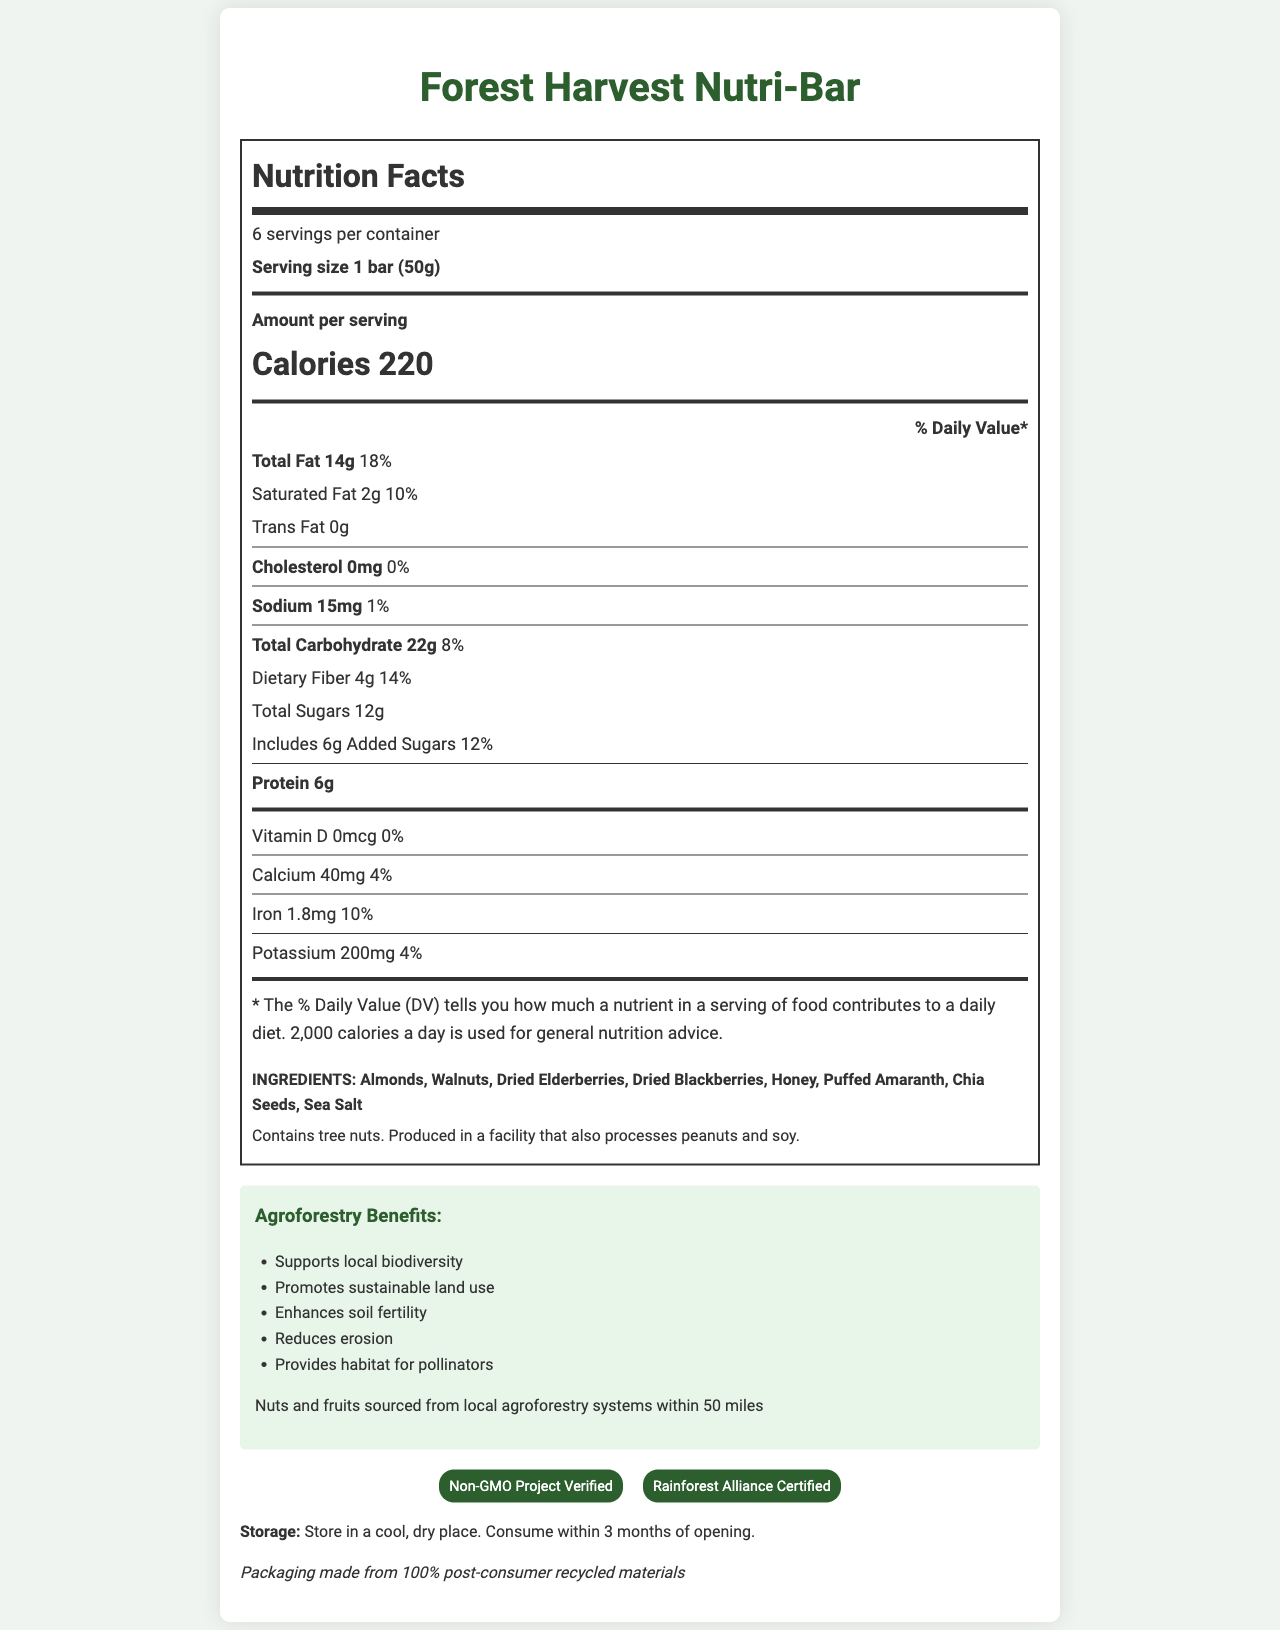what is the serving size of the Forest Harvest Nutri-Bar? The serving size is explicitly mentioned as "1 bar (50g)" in the nutrition label.
Answer: 1 bar (50g) how many servings are there per container? The label clearly states that there are 6 servings per container.
Answer: 6 how many calories are there per serving? The amount of calories per serving is listed as 220.
Answer: 220 what is the amount of total fat in one serving? The total fat amount per serving is listed on the label as 14g.
Answer: 14g how much protein does one serving contain? The label indicates that one serving contains 6g of protein.
Answer: 6g What is the percentage of the daily value for saturated fat per serving? The nutrition label shows that saturated fat is 2g, which is 10% of the daily value.
Answer: 10% Which of the following is included in the ingredients? A. Peanuts B. Almonds C. Cashews The ingredients list does not include peanuts or cashews but does list almonds.
Answer: B What certifications does the Forest Harvest Nutri-Bar have? A. Non-GMO Project Verified B. Certified Organic C. Fair Trade Certified The label only mentions "Non-GMO Project Verified" and "Rainforest Alliance Certified."
Answer: A Is the Forest Harvest Nutri-Bar gluten-free? The document provides no information if the product is gluten-free.
Answer: Not enough information does this snack bar contain any cholesterol? The nutrition label shows 0mg of cholesterol.
Answer: No summarize the main idea of the document. The document provides a detailed view of the nutritional facts, ingredient list, sourcing information, and agroforestry benefits associated with the Forest Harvest Nutri-Bar.
Answer: The Forest Harvest Nutri-Bar is a locally-sourced, nutritious snack made from tree nuts and forest fruits. It supports environmental sustainability and provides nutritional information such as calories, fats, carbohydrates, and protein per serving. does the bar contain any added sugars? The label indicates that there are 6g of added sugars per serving.
Answer: Yes what are the agroforestry benefits associated with this product? The document contains a section listing the agroforestry benefits.
Answer: Supports local biodiversity, Promotes sustainable land use, Enhances soil fertility, Reduces erosion, Provides habitat for pollinators how much potassium is provided per serving? The nutrition label shows that each serving contains 200mg of potassium.
Answer: 200mg where are the nuts and fruits sourced from? The sourcing information specifies that nuts and fruits are locally sourced within 50 miles.
Answer: Within 50 miles from local agroforestry systems what is the percentage of daily value for dietary fiber per serving? The label states that dietary fiber is 4g, which is 14% of the daily value.
Answer: 14% are there any allergens in the Forest Harvest Nutri-Bar? The allergen information indicates the presence of tree nuts and also mentions that the product is processed in a facility that processes peanuts and soy.
Answer: Yes, tree nuts. 